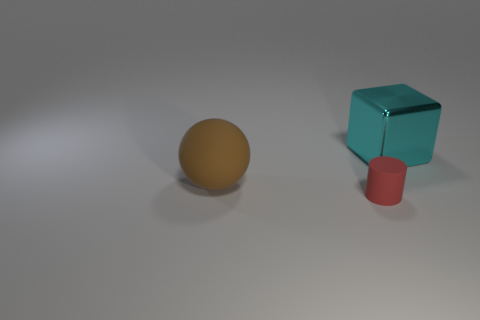How many other objects are there of the same size as the cyan metal block? There is one object of a similar size to the cyan metal block. The red cylinder appears to have a comparable height but its shape is different – it's a cylinder rather than a cube. 